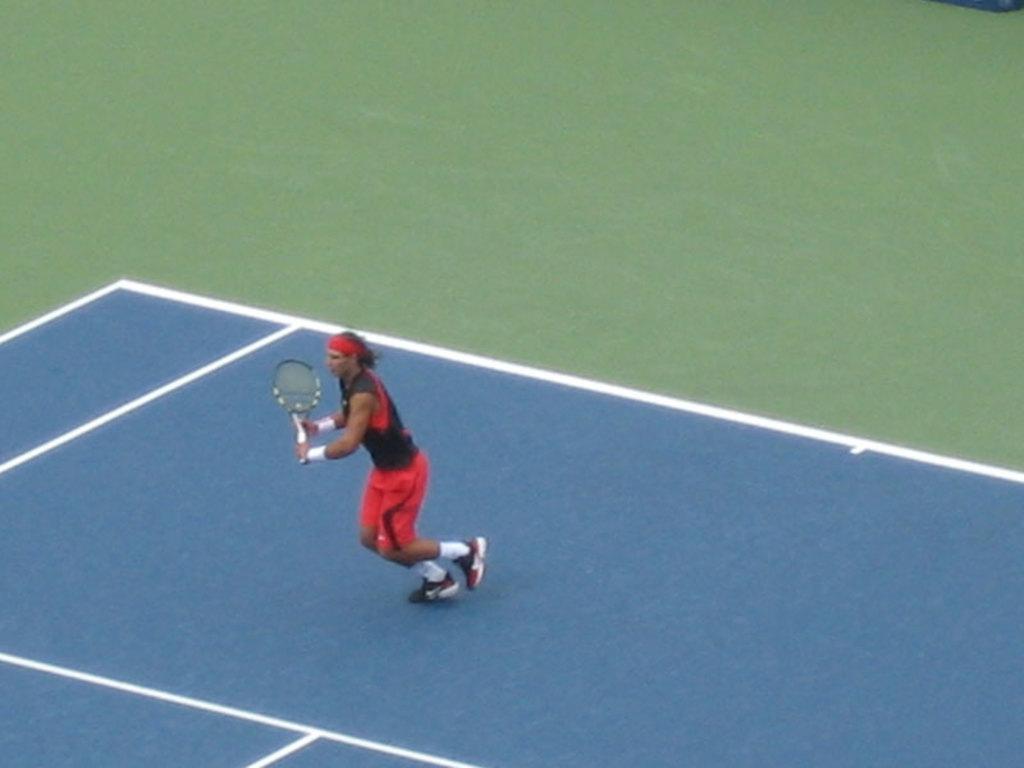Describe this image in one or two sentences. In this image I see a man over here who is wearing black and red jersey and I see that he is holding a racket in his hands and I see the tennis court which is of white, blue and green in color. 